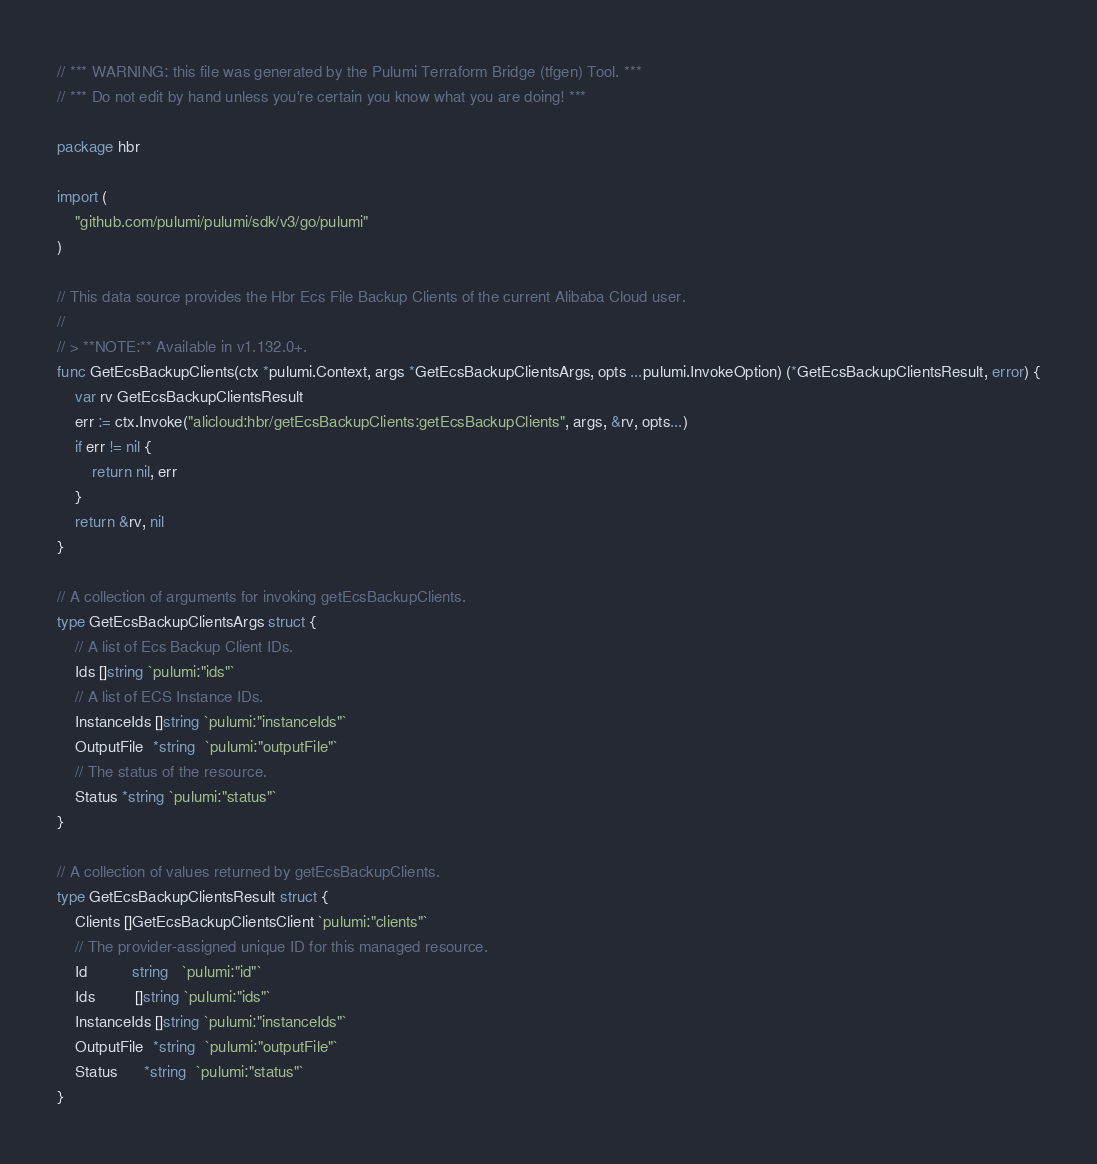Convert code to text. <code><loc_0><loc_0><loc_500><loc_500><_Go_>// *** WARNING: this file was generated by the Pulumi Terraform Bridge (tfgen) Tool. ***
// *** Do not edit by hand unless you're certain you know what you are doing! ***

package hbr

import (
	"github.com/pulumi/pulumi/sdk/v3/go/pulumi"
)

// This data source provides the Hbr Ecs File Backup Clients of the current Alibaba Cloud user.
//
// > **NOTE:** Available in v1.132.0+.
func GetEcsBackupClients(ctx *pulumi.Context, args *GetEcsBackupClientsArgs, opts ...pulumi.InvokeOption) (*GetEcsBackupClientsResult, error) {
	var rv GetEcsBackupClientsResult
	err := ctx.Invoke("alicloud:hbr/getEcsBackupClients:getEcsBackupClients", args, &rv, opts...)
	if err != nil {
		return nil, err
	}
	return &rv, nil
}

// A collection of arguments for invoking getEcsBackupClients.
type GetEcsBackupClientsArgs struct {
	// A list of Ecs Backup Client IDs.
	Ids []string `pulumi:"ids"`
	// A list of ECS Instance IDs.
	InstanceIds []string `pulumi:"instanceIds"`
	OutputFile  *string  `pulumi:"outputFile"`
	// The status of the resource.
	Status *string `pulumi:"status"`
}

// A collection of values returned by getEcsBackupClients.
type GetEcsBackupClientsResult struct {
	Clients []GetEcsBackupClientsClient `pulumi:"clients"`
	// The provider-assigned unique ID for this managed resource.
	Id          string   `pulumi:"id"`
	Ids         []string `pulumi:"ids"`
	InstanceIds []string `pulumi:"instanceIds"`
	OutputFile  *string  `pulumi:"outputFile"`
	Status      *string  `pulumi:"status"`
}
</code> 